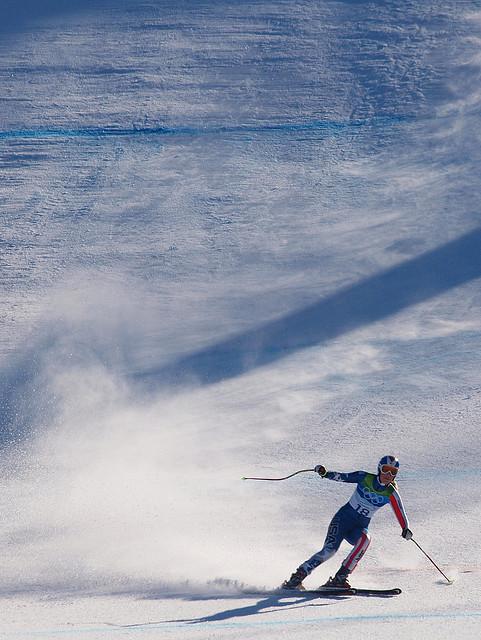Are the skiers riding downhill?
Concise answer only. Yes. Are they taking a break?
Give a very brief answer. No. What is he doing?
Write a very short answer. Skiing. Why is the number on the man's shirt?
Give a very brief answer. 10. Is there an avalanche threatening the skier?
Quick response, please. No. What is the guy doing?
Quick response, please. Skiing. What safety equipment is the man using?
Give a very brief answer. Helmet. How many people are shown?
Be succinct. 1. Is the man doing this for pleasure?
Concise answer only. No. What is the person doing?
Write a very short answer. Skiing. Is she speeding up or slowing down?
Write a very short answer. Slowing down. What exact speed is he traveling?
Write a very short answer. 20 mph. Where was it taken?
Answer briefly. Ski slope. What number is on his shirt?
Quick response, please. 18. What are the blue lines?
Short answer required. Shadows. 